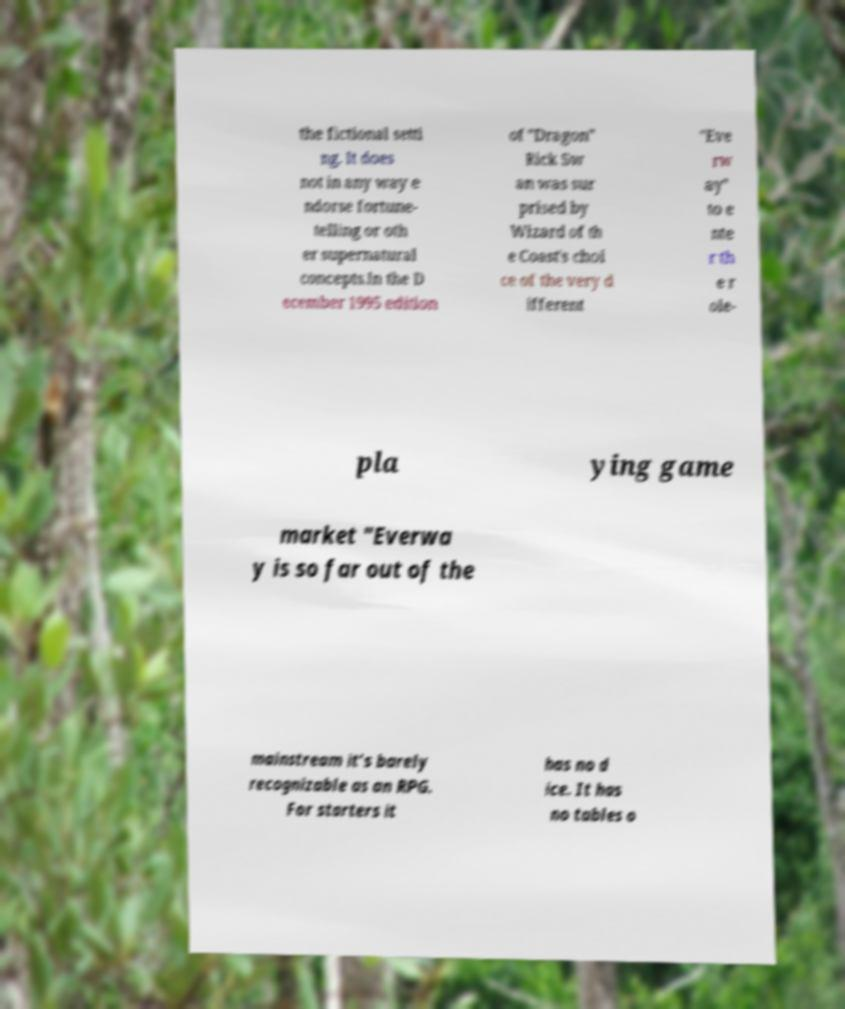There's text embedded in this image that I need extracted. Can you transcribe it verbatim? the fictional setti ng. It does not in any way e ndorse fortune- telling or oth er supernatural concepts.In the D ecember 1995 edition of "Dragon" Rick Sw an was sur prised by Wizard of th e Coast's choi ce of the very d ifferent "Eve rw ay" to e nte r th e r ole- pla ying game market "Everwa y is so far out of the mainstream it’s barely recognizable as an RPG. For starters it has no d ice. It has no tables o 